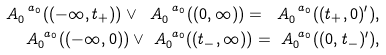<formula> <loc_0><loc_0><loc_500><loc_500>\ A _ { 0 } ^ { \ a _ { 0 } } ( ( - \infty , t _ { + } ) ) \vee \ A _ { 0 } ^ { \ a _ { 0 } } ( ( 0 , \infty ) ) = \ A _ { 0 } ^ { \ a _ { 0 } } ( ( t _ { + } , 0 ) ^ { \prime } ) , \\ \ A _ { 0 } ^ { \ a _ { 0 } } ( ( - \infty , 0 ) ) \vee \ A _ { 0 } ^ { \ a _ { 0 } } ( ( t _ { - } , \infty ) ) = \ A _ { 0 } ^ { \ a _ { 0 } } ( ( 0 , t _ { - } ) ^ { \prime } ) ,</formula> 